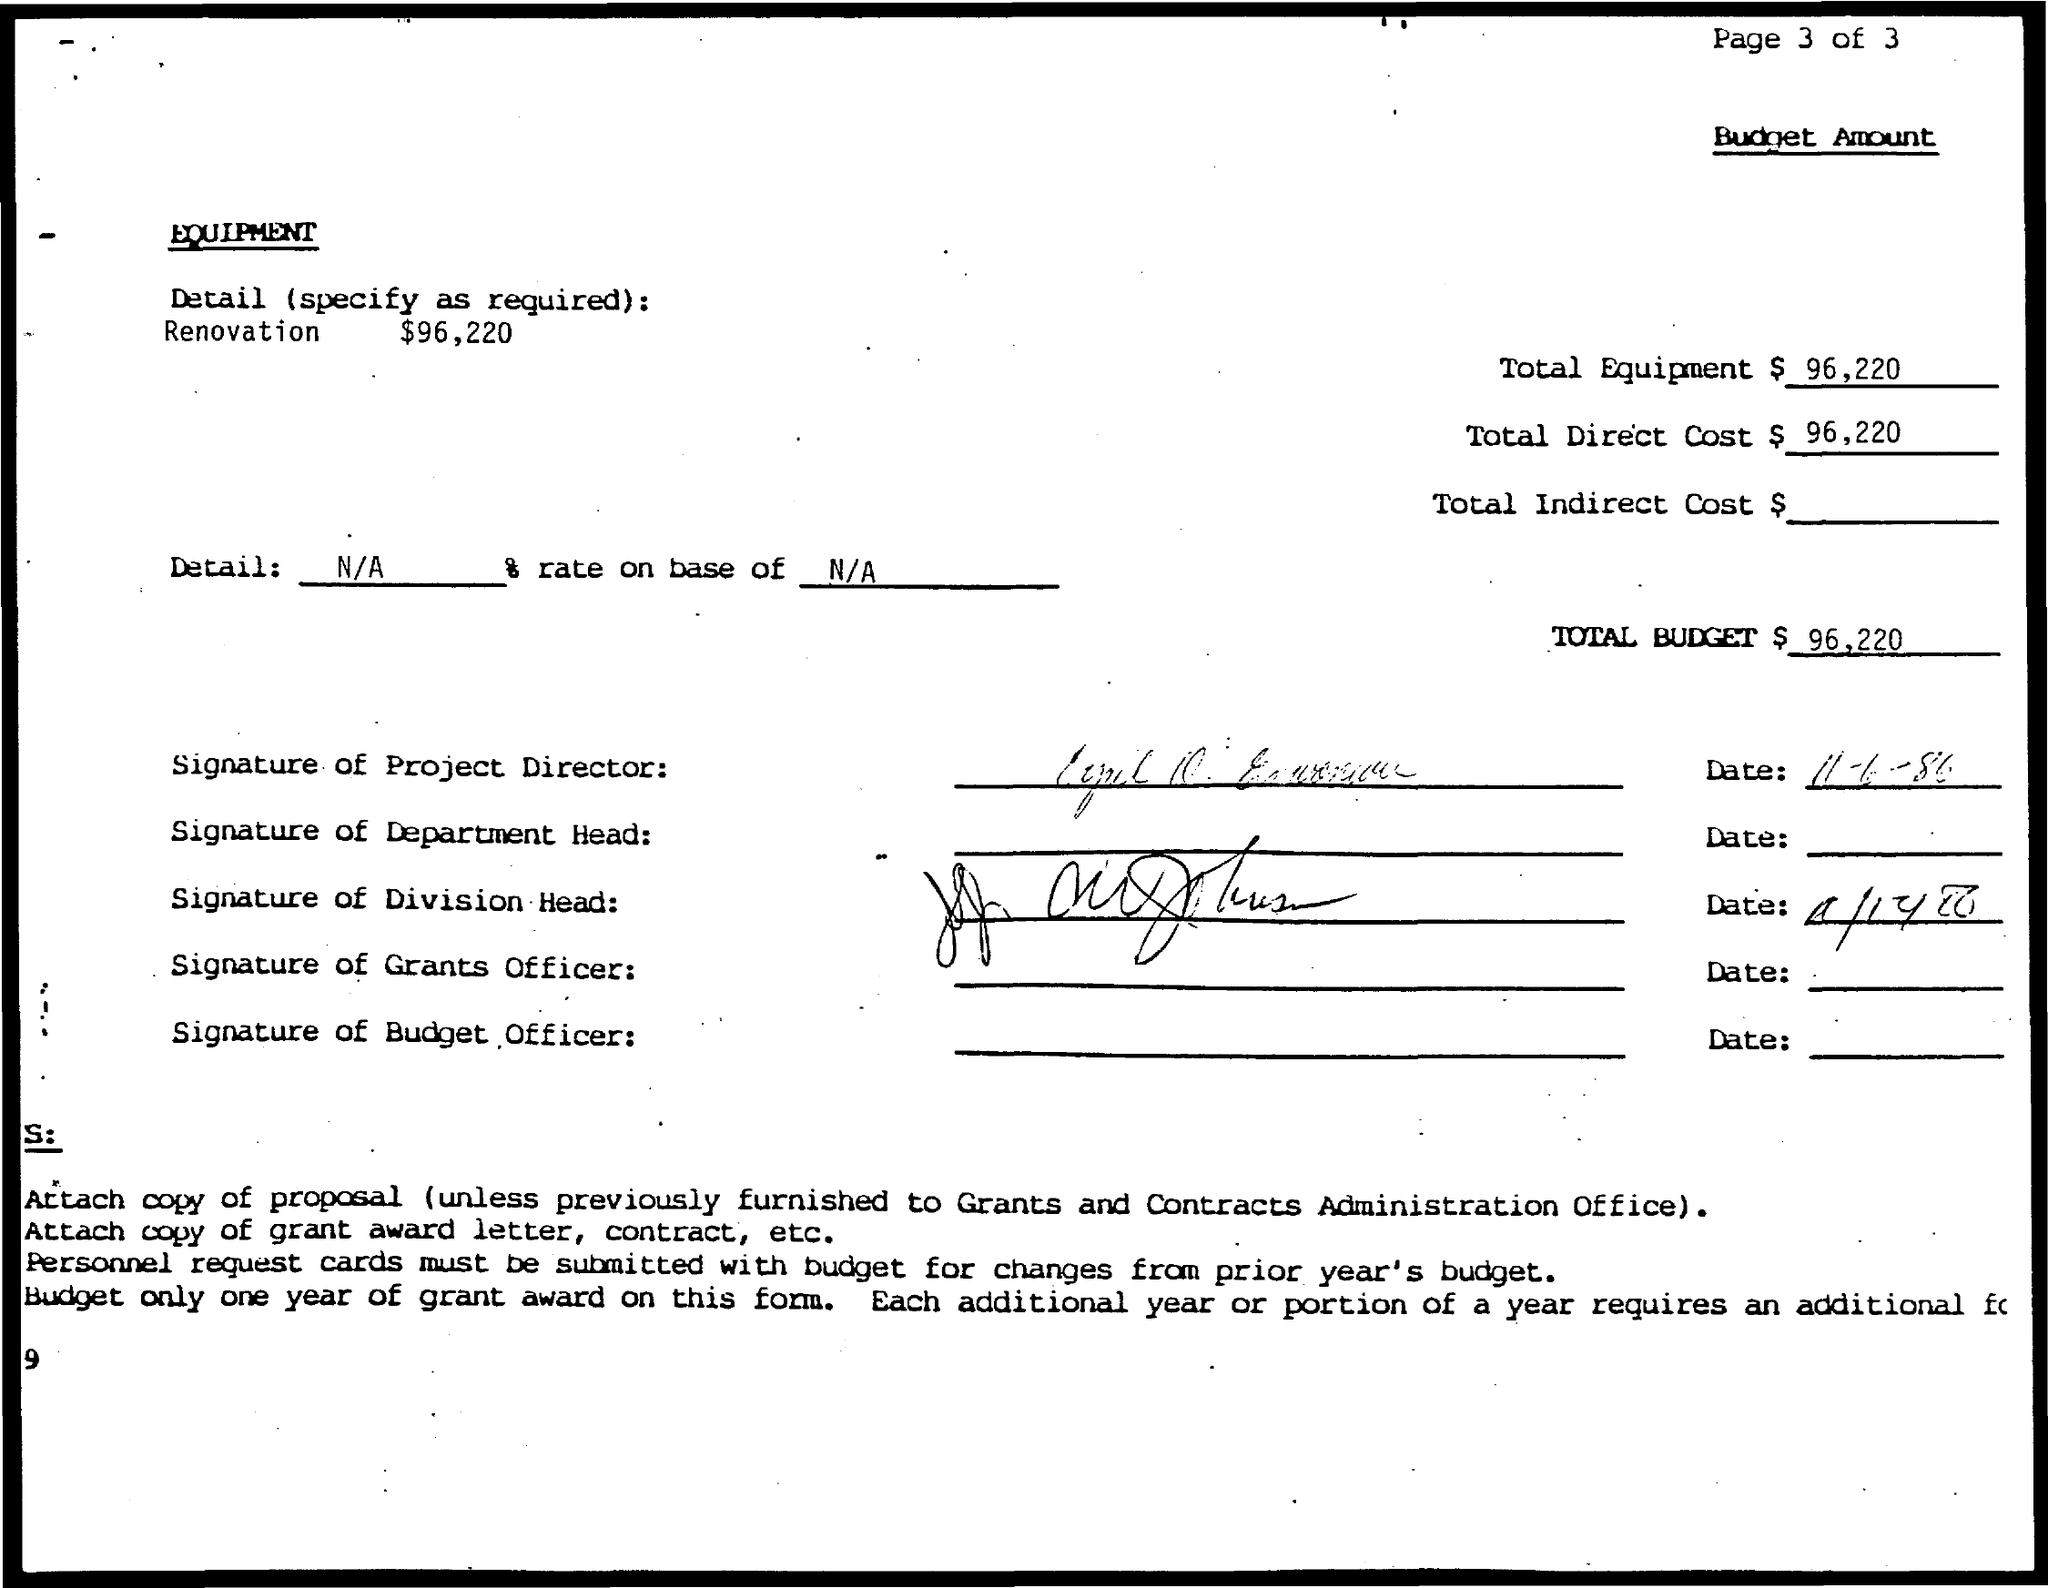Mention a couple of crucial points in this snapshot. The first signature on this document was made by the project director. The total budget is $96,220. 